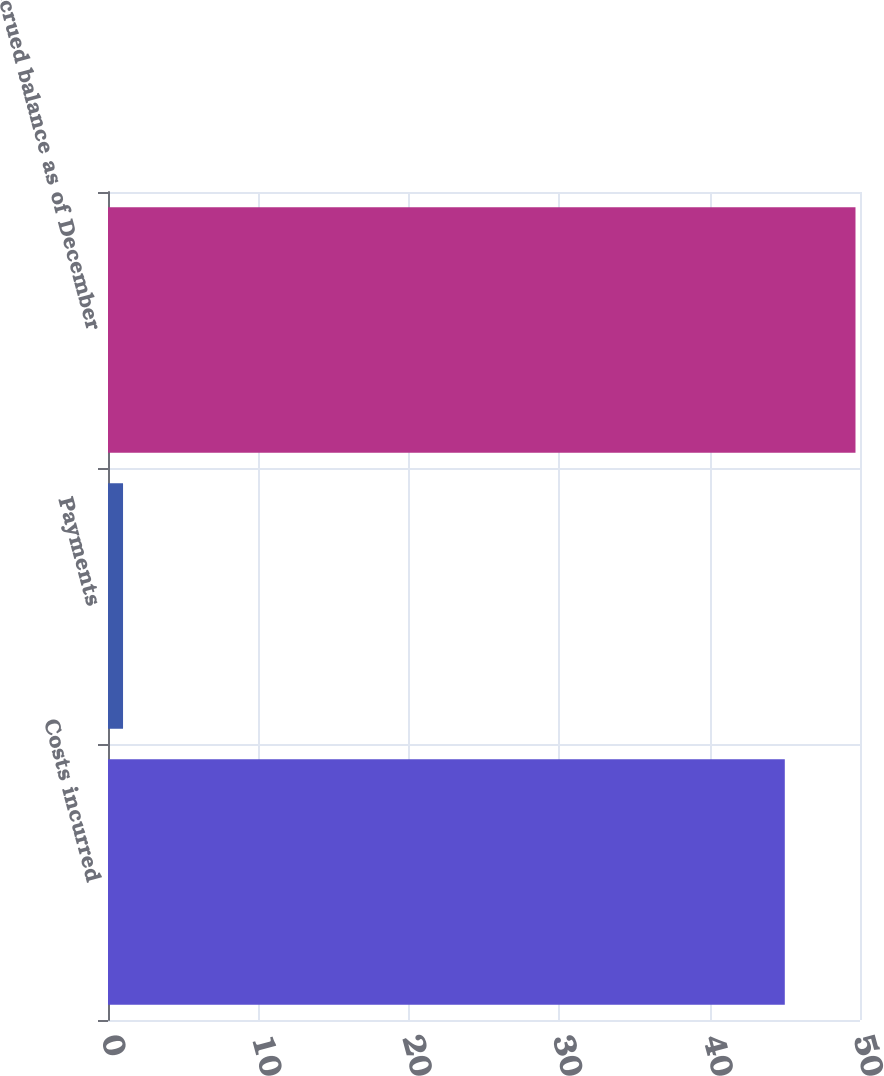<chart> <loc_0><loc_0><loc_500><loc_500><bar_chart><fcel>Costs incurred<fcel>Payments<fcel>Accrued balance as of December<nl><fcel>45<fcel>1<fcel>49.7<nl></chart> 